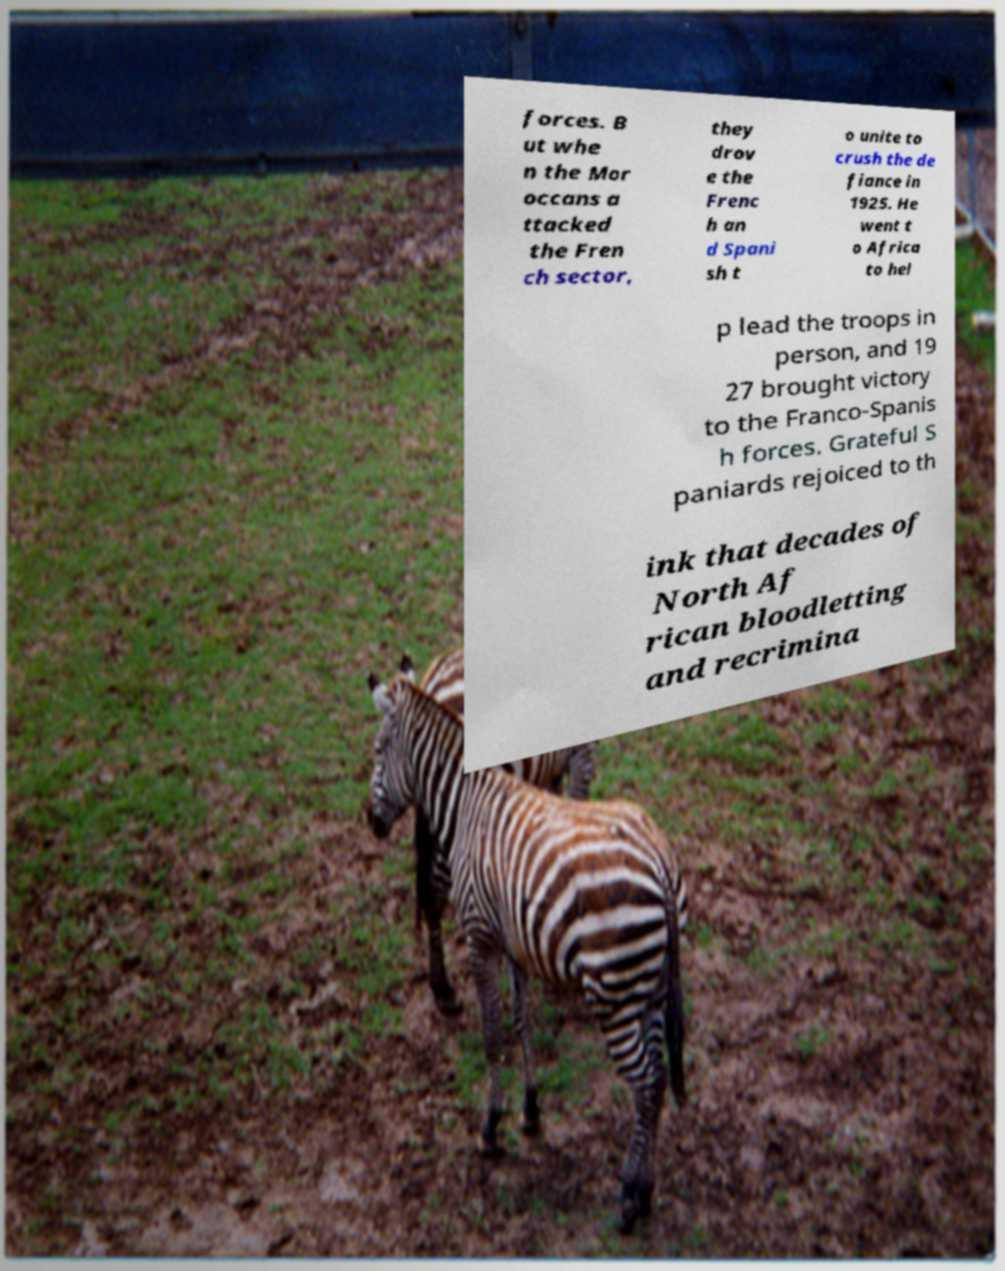What messages or text are displayed in this image? I need them in a readable, typed format. forces. B ut whe n the Mor occans a ttacked the Fren ch sector, they drov e the Frenc h an d Spani sh t o unite to crush the de fiance in 1925. He went t o Africa to hel p lead the troops in person, and 19 27 brought victory to the Franco-Spanis h forces. Grateful S paniards rejoiced to th ink that decades of North Af rican bloodletting and recrimina 